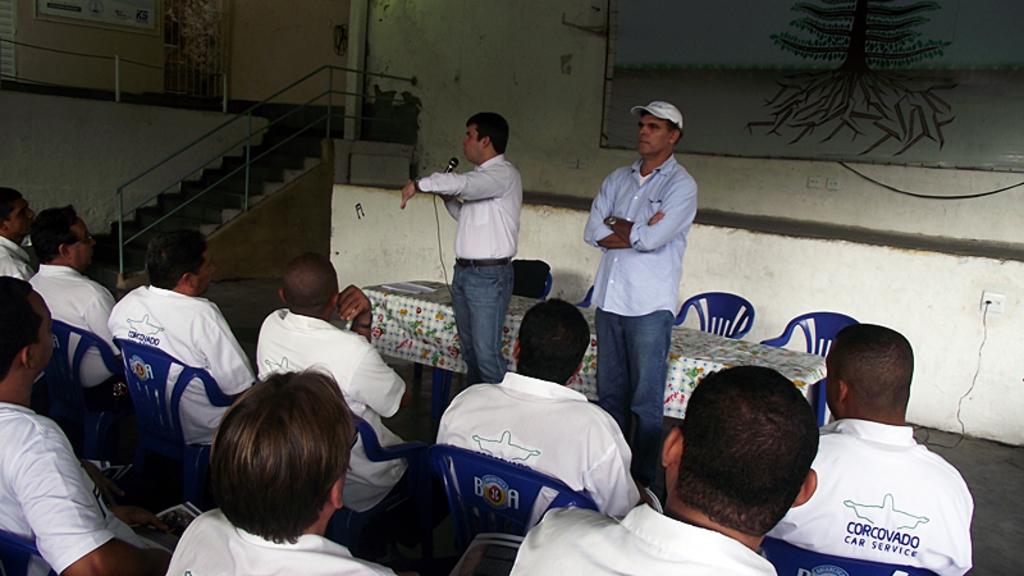What company do these people work for?
Give a very brief answer. Corcovado car service. What type of company is this?
Your response must be concise. Car service. 